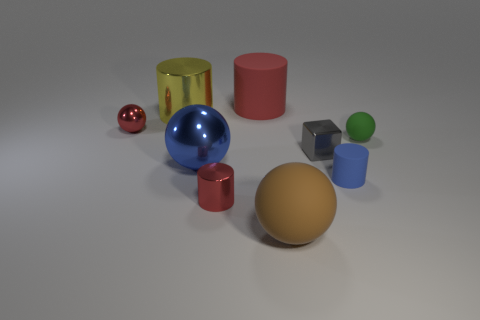Subtract all large shiny balls. How many balls are left? 3 Subtract 2 spheres. How many spheres are left? 2 Add 1 brown spheres. How many objects exist? 10 Subtract all green cylinders. Subtract all cyan blocks. How many cylinders are left? 4 Subtract all cylinders. How many objects are left? 5 Add 7 large brown matte spheres. How many large brown matte spheres are left? 8 Add 3 small blue objects. How many small blue objects exist? 4 Subtract 0 purple cubes. How many objects are left? 9 Subtract all small matte spheres. Subtract all large balls. How many objects are left? 6 